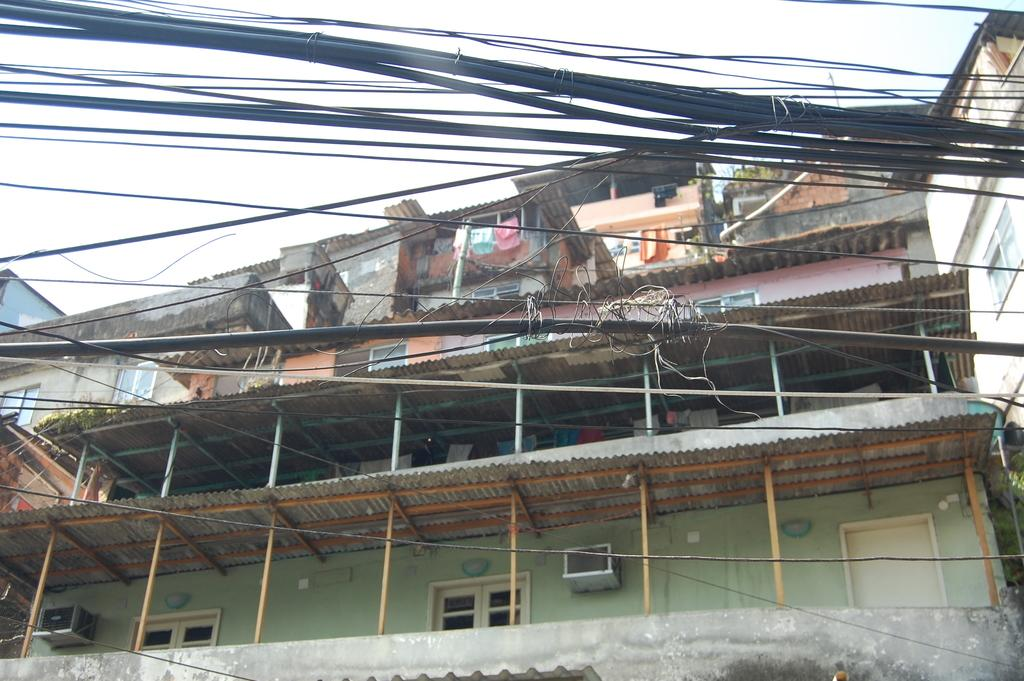What structure is the main subject of the image? There is a building in the image. What is hanging on the building? The building has clothes hanging on it. What type of vegetation is near the building? There are plants near the building. What else can be seen in the front side of the image? There are wires visible in the front side of the image. What is visible at the top of the image? The sky is visible at the top of the image. Can you tell me how many nerves are connected to the wrist in the image? There are no nerves or wrists present in the image; it features a building with clothes hanging on it, plants, wires, and a visible sky. What type of railway is visible in the image? There is no railway present in the image. 